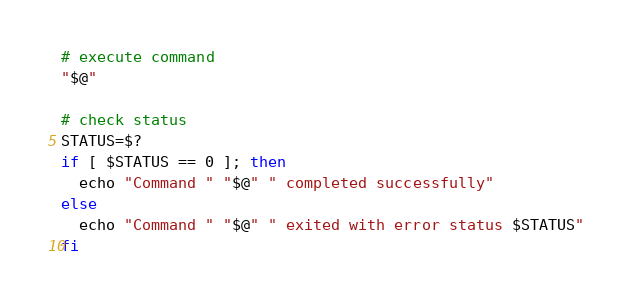Convert code to text. <code><loc_0><loc_0><loc_500><loc_500><_Bash_># execute command
"$@"

# check status
STATUS=$?
if [ $STATUS == 0 ]; then
  echo "Command " "$@" " completed successfully"
else
  echo "Command " "$@" " exited with error status $STATUS"
fi
</code> 